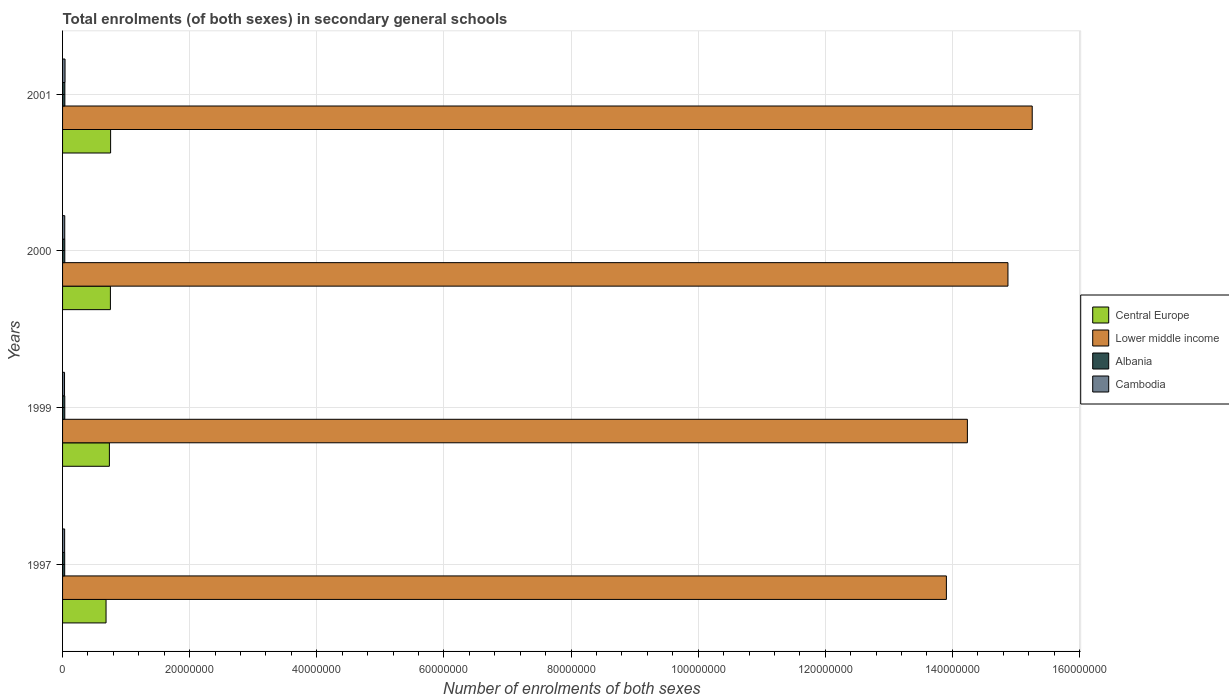How many groups of bars are there?
Provide a succinct answer. 4. How many bars are there on the 4th tick from the top?
Provide a short and direct response. 4. How many bars are there on the 2nd tick from the bottom?
Provide a succinct answer. 4. What is the label of the 4th group of bars from the top?
Offer a terse response. 1997. In how many cases, is the number of bars for a given year not equal to the number of legend labels?
Make the answer very short. 0. What is the number of enrolments in secondary schools in Central Europe in 1999?
Your answer should be very brief. 7.37e+06. Across all years, what is the maximum number of enrolments in secondary schools in Central Europe?
Offer a terse response. 7.56e+06. Across all years, what is the minimum number of enrolments in secondary schools in Albania?
Give a very brief answer. 3.34e+05. In which year was the number of enrolments in secondary schools in Cambodia maximum?
Keep it short and to the point. 2001. What is the total number of enrolments in secondary schools in Central Europe in the graph?
Provide a succinct answer. 2.93e+07. What is the difference between the number of enrolments in secondary schools in Lower middle income in 1999 and that in 2000?
Provide a succinct answer. -6.38e+06. What is the difference between the number of enrolments in secondary schools in Central Europe in 1997 and the number of enrolments in secondary schools in Lower middle income in 1999?
Your response must be concise. -1.36e+08. What is the average number of enrolments in secondary schools in Cambodia per year?
Your answer should be very brief. 3.42e+05. In the year 1999, what is the difference between the number of enrolments in secondary schools in Central Europe and number of enrolments in secondary schools in Cambodia?
Your answer should be very brief. 7.06e+06. In how many years, is the number of enrolments in secondary schools in Albania greater than 44000000 ?
Your answer should be very brief. 0. What is the ratio of the number of enrolments in secondary schools in Cambodia in 1999 to that in 2000?
Ensure brevity in your answer.  0.9. Is the number of enrolments in secondary schools in Albania in 2000 less than that in 2001?
Your response must be concise. Yes. Is the difference between the number of enrolments in secondary schools in Central Europe in 2000 and 2001 greater than the difference between the number of enrolments in secondary schools in Cambodia in 2000 and 2001?
Provide a succinct answer. Yes. What is the difference between the highest and the second highest number of enrolments in secondary schools in Central Europe?
Keep it short and to the point. 3.40e+04. What is the difference between the highest and the lowest number of enrolments in secondary schools in Lower middle income?
Ensure brevity in your answer.  1.35e+07. In how many years, is the number of enrolments in secondary schools in Lower middle income greater than the average number of enrolments in secondary schools in Lower middle income taken over all years?
Ensure brevity in your answer.  2. Is the sum of the number of enrolments in secondary schools in Central Europe in 1999 and 2000 greater than the maximum number of enrolments in secondary schools in Lower middle income across all years?
Provide a short and direct response. No. Is it the case that in every year, the sum of the number of enrolments in secondary schools in Albania and number of enrolments in secondary schools in Lower middle income is greater than the sum of number of enrolments in secondary schools in Cambodia and number of enrolments in secondary schools in Central Europe?
Give a very brief answer. Yes. What does the 4th bar from the top in 1997 represents?
Give a very brief answer. Central Europe. What does the 4th bar from the bottom in 2001 represents?
Make the answer very short. Cambodia. Is it the case that in every year, the sum of the number of enrolments in secondary schools in Albania and number of enrolments in secondary schools in Central Europe is greater than the number of enrolments in secondary schools in Lower middle income?
Provide a succinct answer. No. How many bars are there?
Give a very brief answer. 16. What is the difference between two consecutive major ticks on the X-axis?
Keep it short and to the point. 2.00e+07. Where does the legend appear in the graph?
Give a very brief answer. Center right. What is the title of the graph?
Offer a very short reply. Total enrolments (of both sexes) in secondary general schools. Does "Paraguay" appear as one of the legend labels in the graph?
Provide a succinct answer. No. What is the label or title of the X-axis?
Provide a short and direct response. Number of enrolments of both sexes. What is the Number of enrolments of both sexes in Central Europe in 1997?
Your response must be concise. 6.84e+06. What is the Number of enrolments of both sexes of Lower middle income in 1997?
Offer a terse response. 1.39e+08. What is the Number of enrolments of both sexes of Albania in 1997?
Ensure brevity in your answer.  3.34e+05. What is the Number of enrolments of both sexes in Cambodia in 1997?
Offer a terse response. 3.28e+05. What is the Number of enrolments of both sexes in Central Europe in 1999?
Your response must be concise. 7.37e+06. What is the Number of enrolments of both sexes in Lower middle income in 1999?
Offer a very short reply. 1.42e+08. What is the Number of enrolments of both sexes in Albania in 1999?
Your answer should be compact. 3.48e+05. What is the Number of enrolments of both sexes in Cambodia in 1999?
Provide a succinct answer. 3.08e+05. What is the Number of enrolments of both sexes of Central Europe in 2000?
Your answer should be compact. 7.53e+06. What is the Number of enrolments of both sexes in Lower middle income in 2000?
Make the answer very short. 1.49e+08. What is the Number of enrolments of both sexes in Albania in 2000?
Provide a short and direct response. 3.51e+05. What is the Number of enrolments of both sexes of Cambodia in 2000?
Offer a very short reply. 3.43e+05. What is the Number of enrolments of both sexes of Central Europe in 2001?
Ensure brevity in your answer.  7.56e+06. What is the Number of enrolments of both sexes in Lower middle income in 2001?
Your response must be concise. 1.53e+08. What is the Number of enrolments of both sexes of Albania in 2001?
Offer a very short reply. 3.62e+05. What is the Number of enrolments of both sexes of Cambodia in 2001?
Offer a very short reply. 3.89e+05. Across all years, what is the maximum Number of enrolments of both sexes in Central Europe?
Offer a very short reply. 7.56e+06. Across all years, what is the maximum Number of enrolments of both sexes of Lower middle income?
Provide a succinct answer. 1.53e+08. Across all years, what is the maximum Number of enrolments of both sexes of Albania?
Keep it short and to the point. 3.62e+05. Across all years, what is the maximum Number of enrolments of both sexes in Cambodia?
Ensure brevity in your answer.  3.89e+05. Across all years, what is the minimum Number of enrolments of both sexes of Central Europe?
Make the answer very short. 6.84e+06. Across all years, what is the minimum Number of enrolments of both sexes in Lower middle income?
Offer a terse response. 1.39e+08. Across all years, what is the minimum Number of enrolments of both sexes in Albania?
Provide a short and direct response. 3.34e+05. Across all years, what is the minimum Number of enrolments of both sexes of Cambodia?
Your response must be concise. 3.08e+05. What is the total Number of enrolments of both sexes in Central Europe in the graph?
Your answer should be compact. 2.93e+07. What is the total Number of enrolments of both sexes of Lower middle income in the graph?
Keep it short and to the point. 5.83e+08. What is the total Number of enrolments of both sexes in Albania in the graph?
Provide a succinct answer. 1.39e+06. What is the total Number of enrolments of both sexes in Cambodia in the graph?
Your response must be concise. 1.37e+06. What is the difference between the Number of enrolments of both sexes in Central Europe in 1997 and that in 1999?
Offer a terse response. -5.25e+05. What is the difference between the Number of enrolments of both sexes of Lower middle income in 1997 and that in 1999?
Your answer should be compact. -3.30e+06. What is the difference between the Number of enrolments of both sexes of Albania in 1997 and that in 1999?
Make the answer very short. -1.48e+04. What is the difference between the Number of enrolments of both sexes in Cambodia in 1997 and that in 1999?
Your response must be concise. 1.94e+04. What is the difference between the Number of enrolments of both sexes in Central Europe in 1997 and that in 2000?
Give a very brief answer. -6.85e+05. What is the difference between the Number of enrolments of both sexes in Lower middle income in 1997 and that in 2000?
Offer a very short reply. -9.69e+06. What is the difference between the Number of enrolments of both sexes of Albania in 1997 and that in 2000?
Ensure brevity in your answer.  -1.76e+04. What is the difference between the Number of enrolments of both sexes of Cambodia in 1997 and that in 2000?
Give a very brief answer. -1.57e+04. What is the difference between the Number of enrolments of both sexes of Central Europe in 1997 and that in 2001?
Offer a very short reply. -7.19e+05. What is the difference between the Number of enrolments of both sexes in Lower middle income in 1997 and that in 2001?
Offer a terse response. -1.35e+07. What is the difference between the Number of enrolments of both sexes of Albania in 1997 and that in 2001?
Provide a succinct answer. -2.80e+04. What is the difference between the Number of enrolments of both sexes in Cambodia in 1997 and that in 2001?
Offer a terse response. -6.15e+04. What is the difference between the Number of enrolments of both sexes of Central Europe in 1999 and that in 2000?
Make the answer very short. -1.60e+05. What is the difference between the Number of enrolments of both sexes of Lower middle income in 1999 and that in 2000?
Provide a short and direct response. -6.38e+06. What is the difference between the Number of enrolments of both sexes in Albania in 1999 and that in 2000?
Offer a terse response. -2794. What is the difference between the Number of enrolments of both sexes in Cambodia in 1999 and that in 2000?
Offer a terse response. -3.51e+04. What is the difference between the Number of enrolments of both sexes of Central Europe in 1999 and that in 2001?
Your answer should be very brief. -1.94e+05. What is the difference between the Number of enrolments of both sexes of Lower middle income in 1999 and that in 2001?
Provide a short and direct response. -1.02e+07. What is the difference between the Number of enrolments of both sexes in Albania in 1999 and that in 2001?
Provide a short and direct response. -1.32e+04. What is the difference between the Number of enrolments of both sexes of Cambodia in 1999 and that in 2001?
Ensure brevity in your answer.  -8.09e+04. What is the difference between the Number of enrolments of both sexes in Central Europe in 2000 and that in 2001?
Provide a succinct answer. -3.40e+04. What is the difference between the Number of enrolments of both sexes of Lower middle income in 2000 and that in 2001?
Your response must be concise. -3.82e+06. What is the difference between the Number of enrolments of both sexes in Albania in 2000 and that in 2001?
Offer a very short reply. -1.04e+04. What is the difference between the Number of enrolments of both sexes of Cambodia in 2000 and that in 2001?
Provide a short and direct response. -4.57e+04. What is the difference between the Number of enrolments of both sexes of Central Europe in 1997 and the Number of enrolments of both sexes of Lower middle income in 1999?
Your answer should be very brief. -1.36e+08. What is the difference between the Number of enrolments of both sexes of Central Europe in 1997 and the Number of enrolments of both sexes of Albania in 1999?
Make the answer very short. 6.49e+06. What is the difference between the Number of enrolments of both sexes in Central Europe in 1997 and the Number of enrolments of both sexes in Cambodia in 1999?
Your answer should be very brief. 6.53e+06. What is the difference between the Number of enrolments of both sexes in Lower middle income in 1997 and the Number of enrolments of both sexes in Albania in 1999?
Your answer should be compact. 1.39e+08. What is the difference between the Number of enrolments of both sexes in Lower middle income in 1997 and the Number of enrolments of both sexes in Cambodia in 1999?
Ensure brevity in your answer.  1.39e+08. What is the difference between the Number of enrolments of both sexes of Albania in 1997 and the Number of enrolments of both sexes of Cambodia in 1999?
Keep it short and to the point. 2.54e+04. What is the difference between the Number of enrolments of both sexes in Central Europe in 1997 and the Number of enrolments of both sexes in Lower middle income in 2000?
Offer a very short reply. -1.42e+08. What is the difference between the Number of enrolments of both sexes of Central Europe in 1997 and the Number of enrolments of both sexes of Albania in 2000?
Your response must be concise. 6.49e+06. What is the difference between the Number of enrolments of both sexes of Central Europe in 1997 and the Number of enrolments of both sexes of Cambodia in 2000?
Provide a succinct answer. 6.50e+06. What is the difference between the Number of enrolments of both sexes in Lower middle income in 1997 and the Number of enrolments of both sexes in Albania in 2000?
Offer a very short reply. 1.39e+08. What is the difference between the Number of enrolments of both sexes in Lower middle income in 1997 and the Number of enrolments of both sexes in Cambodia in 2000?
Ensure brevity in your answer.  1.39e+08. What is the difference between the Number of enrolments of both sexes of Albania in 1997 and the Number of enrolments of both sexes of Cambodia in 2000?
Give a very brief answer. -9785. What is the difference between the Number of enrolments of both sexes of Central Europe in 1997 and the Number of enrolments of both sexes of Lower middle income in 2001?
Provide a succinct answer. -1.46e+08. What is the difference between the Number of enrolments of both sexes in Central Europe in 1997 and the Number of enrolments of both sexes in Albania in 2001?
Give a very brief answer. 6.48e+06. What is the difference between the Number of enrolments of both sexes in Central Europe in 1997 and the Number of enrolments of both sexes in Cambodia in 2001?
Offer a very short reply. 6.45e+06. What is the difference between the Number of enrolments of both sexes in Lower middle income in 1997 and the Number of enrolments of both sexes in Albania in 2001?
Your response must be concise. 1.39e+08. What is the difference between the Number of enrolments of both sexes of Lower middle income in 1997 and the Number of enrolments of both sexes of Cambodia in 2001?
Your answer should be compact. 1.39e+08. What is the difference between the Number of enrolments of both sexes of Albania in 1997 and the Number of enrolments of both sexes of Cambodia in 2001?
Offer a very short reply. -5.55e+04. What is the difference between the Number of enrolments of both sexes of Central Europe in 1999 and the Number of enrolments of both sexes of Lower middle income in 2000?
Your answer should be compact. -1.41e+08. What is the difference between the Number of enrolments of both sexes of Central Europe in 1999 and the Number of enrolments of both sexes of Albania in 2000?
Give a very brief answer. 7.01e+06. What is the difference between the Number of enrolments of both sexes in Central Europe in 1999 and the Number of enrolments of both sexes in Cambodia in 2000?
Ensure brevity in your answer.  7.02e+06. What is the difference between the Number of enrolments of both sexes in Lower middle income in 1999 and the Number of enrolments of both sexes in Albania in 2000?
Make the answer very short. 1.42e+08. What is the difference between the Number of enrolments of both sexes of Lower middle income in 1999 and the Number of enrolments of both sexes of Cambodia in 2000?
Offer a very short reply. 1.42e+08. What is the difference between the Number of enrolments of both sexes in Albania in 1999 and the Number of enrolments of both sexes in Cambodia in 2000?
Keep it short and to the point. 5061. What is the difference between the Number of enrolments of both sexes in Central Europe in 1999 and the Number of enrolments of both sexes in Lower middle income in 2001?
Your answer should be very brief. -1.45e+08. What is the difference between the Number of enrolments of both sexes of Central Europe in 1999 and the Number of enrolments of both sexes of Albania in 2001?
Your response must be concise. 7.00e+06. What is the difference between the Number of enrolments of both sexes in Central Europe in 1999 and the Number of enrolments of both sexes in Cambodia in 2001?
Offer a very short reply. 6.98e+06. What is the difference between the Number of enrolments of both sexes of Lower middle income in 1999 and the Number of enrolments of both sexes of Albania in 2001?
Ensure brevity in your answer.  1.42e+08. What is the difference between the Number of enrolments of both sexes in Lower middle income in 1999 and the Number of enrolments of both sexes in Cambodia in 2001?
Keep it short and to the point. 1.42e+08. What is the difference between the Number of enrolments of both sexes of Albania in 1999 and the Number of enrolments of both sexes of Cambodia in 2001?
Offer a terse response. -4.07e+04. What is the difference between the Number of enrolments of both sexes of Central Europe in 2000 and the Number of enrolments of both sexes of Lower middle income in 2001?
Offer a terse response. -1.45e+08. What is the difference between the Number of enrolments of both sexes of Central Europe in 2000 and the Number of enrolments of both sexes of Albania in 2001?
Your answer should be compact. 7.16e+06. What is the difference between the Number of enrolments of both sexes of Central Europe in 2000 and the Number of enrolments of both sexes of Cambodia in 2001?
Provide a short and direct response. 7.14e+06. What is the difference between the Number of enrolments of both sexes in Lower middle income in 2000 and the Number of enrolments of both sexes in Albania in 2001?
Your answer should be very brief. 1.48e+08. What is the difference between the Number of enrolments of both sexes of Lower middle income in 2000 and the Number of enrolments of both sexes of Cambodia in 2001?
Give a very brief answer. 1.48e+08. What is the difference between the Number of enrolments of both sexes in Albania in 2000 and the Number of enrolments of both sexes in Cambodia in 2001?
Your answer should be compact. -3.79e+04. What is the average Number of enrolments of both sexes in Central Europe per year?
Offer a terse response. 7.32e+06. What is the average Number of enrolments of both sexes of Lower middle income per year?
Give a very brief answer. 1.46e+08. What is the average Number of enrolments of both sexes of Albania per year?
Offer a very short reply. 3.49e+05. What is the average Number of enrolments of both sexes of Cambodia per year?
Your response must be concise. 3.42e+05. In the year 1997, what is the difference between the Number of enrolments of both sexes of Central Europe and Number of enrolments of both sexes of Lower middle income?
Your answer should be very brief. -1.32e+08. In the year 1997, what is the difference between the Number of enrolments of both sexes of Central Europe and Number of enrolments of both sexes of Albania?
Your response must be concise. 6.51e+06. In the year 1997, what is the difference between the Number of enrolments of both sexes of Central Europe and Number of enrolments of both sexes of Cambodia?
Your response must be concise. 6.51e+06. In the year 1997, what is the difference between the Number of enrolments of both sexes of Lower middle income and Number of enrolments of both sexes of Albania?
Keep it short and to the point. 1.39e+08. In the year 1997, what is the difference between the Number of enrolments of both sexes in Lower middle income and Number of enrolments of both sexes in Cambodia?
Ensure brevity in your answer.  1.39e+08. In the year 1997, what is the difference between the Number of enrolments of both sexes in Albania and Number of enrolments of both sexes in Cambodia?
Your answer should be compact. 5957. In the year 1999, what is the difference between the Number of enrolments of both sexes of Central Europe and Number of enrolments of both sexes of Lower middle income?
Provide a succinct answer. -1.35e+08. In the year 1999, what is the difference between the Number of enrolments of both sexes in Central Europe and Number of enrolments of both sexes in Albania?
Offer a terse response. 7.02e+06. In the year 1999, what is the difference between the Number of enrolments of both sexes of Central Europe and Number of enrolments of both sexes of Cambodia?
Provide a short and direct response. 7.06e+06. In the year 1999, what is the difference between the Number of enrolments of both sexes in Lower middle income and Number of enrolments of both sexes in Albania?
Offer a very short reply. 1.42e+08. In the year 1999, what is the difference between the Number of enrolments of both sexes of Lower middle income and Number of enrolments of both sexes of Cambodia?
Your answer should be very brief. 1.42e+08. In the year 1999, what is the difference between the Number of enrolments of both sexes in Albania and Number of enrolments of both sexes in Cambodia?
Provide a succinct answer. 4.02e+04. In the year 2000, what is the difference between the Number of enrolments of both sexes in Central Europe and Number of enrolments of both sexes in Lower middle income?
Keep it short and to the point. -1.41e+08. In the year 2000, what is the difference between the Number of enrolments of both sexes of Central Europe and Number of enrolments of both sexes of Albania?
Your response must be concise. 7.17e+06. In the year 2000, what is the difference between the Number of enrolments of both sexes in Central Europe and Number of enrolments of both sexes in Cambodia?
Your response must be concise. 7.18e+06. In the year 2000, what is the difference between the Number of enrolments of both sexes of Lower middle income and Number of enrolments of both sexes of Albania?
Offer a terse response. 1.48e+08. In the year 2000, what is the difference between the Number of enrolments of both sexes in Lower middle income and Number of enrolments of both sexes in Cambodia?
Make the answer very short. 1.48e+08. In the year 2000, what is the difference between the Number of enrolments of both sexes of Albania and Number of enrolments of both sexes of Cambodia?
Your response must be concise. 7855. In the year 2001, what is the difference between the Number of enrolments of both sexes of Central Europe and Number of enrolments of both sexes of Lower middle income?
Offer a very short reply. -1.45e+08. In the year 2001, what is the difference between the Number of enrolments of both sexes in Central Europe and Number of enrolments of both sexes in Albania?
Offer a very short reply. 7.20e+06. In the year 2001, what is the difference between the Number of enrolments of both sexes in Central Europe and Number of enrolments of both sexes in Cambodia?
Ensure brevity in your answer.  7.17e+06. In the year 2001, what is the difference between the Number of enrolments of both sexes in Lower middle income and Number of enrolments of both sexes in Albania?
Offer a very short reply. 1.52e+08. In the year 2001, what is the difference between the Number of enrolments of both sexes of Lower middle income and Number of enrolments of both sexes of Cambodia?
Ensure brevity in your answer.  1.52e+08. In the year 2001, what is the difference between the Number of enrolments of both sexes in Albania and Number of enrolments of both sexes in Cambodia?
Your response must be concise. -2.75e+04. What is the ratio of the Number of enrolments of both sexes in Central Europe in 1997 to that in 1999?
Your answer should be compact. 0.93. What is the ratio of the Number of enrolments of both sexes of Lower middle income in 1997 to that in 1999?
Give a very brief answer. 0.98. What is the ratio of the Number of enrolments of both sexes in Albania in 1997 to that in 1999?
Make the answer very short. 0.96. What is the ratio of the Number of enrolments of both sexes of Cambodia in 1997 to that in 1999?
Keep it short and to the point. 1.06. What is the ratio of the Number of enrolments of both sexes of Central Europe in 1997 to that in 2000?
Your answer should be very brief. 0.91. What is the ratio of the Number of enrolments of both sexes of Lower middle income in 1997 to that in 2000?
Give a very brief answer. 0.93. What is the ratio of the Number of enrolments of both sexes of Albania in 1997 to that in 2000?
Offer a very short reply. 0.95. What is the ratio of the Number of enrolments of both sexes in Cambodia in 1997 to that in 2000?
Provide a short and direct response. 0.95. What is the ratio of the Number of enrolments of both sexes in Central Europe in 1997 to that in 2001?
Your response must be concise. 0.9. What is the ratio of the Number of enrolments of both sexes of Lower middle income in 1997 to that in 2001?
Provide a short and direct response. 0.91. What is the ratio of the Number of enrolments of both sexes in Albania in 1997 to that in 2001?
Give a very brief answer. 0.92. What is the ratio of the Number of enrolments of both sexes in Cambodia in 1997 to that in 2001?
Your answer should be compact. 0.84. What is the ratio of the Number of enrolments of both sexes in Central Europe in 1999 to that in 2000?
Give a very brief answer. 0.98. What is the ratio of the Number of enrolments of both sexes of Lower middle income in 1999 to that in 2000?
Give a very brief answer. 0.96. What is the ratio of the Number of enrolments of both sexes of Albania in 1999 to that in 2000?
Offer a terse response. 0.99. What is the ratio of the Number of enrolments of both sexes of Cambodia in 1999 to that in 2000?
Give a very brief answer. 0.9. What is the ratio of the Number of enrolments of both sexes of Central Europe in 1999 to that in 2001?
Offer a very short reply. 0.97. What is the ratio of the Number of enrolments of both sexes of Lower middle income in 1999 to that in 2001?
Offer a terse response. 0.93. What is the ratio of the Number of enrolments of both sexes in Albania in 1999 to that in 2001?
Provide a succinct answer. 0.96. What is the ratio of the Number of enrolments of both sexes in Cambodia in 1999 to that in 2001?
Ensure brevity in your answer.  0.79. What is the ratio of the Number of enrolments of both sexes in Lower middle income in 2000 to that in 2001?
Ensure brevity in your answer.  0.97. What is the ratio of the Number of enrolments of both sexes of Albania in 2000 to that in 2001?
Your response must be concise. 0.97. What is the ratio of the Number of enrolments of both sexes of Cambodia in 2000 to that in 2001?
Your answer should be compact. 0.88. What is the difference between the highest and the second highest Number of enrolments of both sexes of Central Europe?
Make the answer very short. 3.40e+04. What is the difference between the highest and the second highest Number of enrolments of both sexes in Lower middle income?
Ensure brevity in your answer.  3.82e+06. What is the difference between the highest and the second highest Number of enrolments of both sexes in Albania?
Make the answer very short. 1.04e+04. What is the difference between the highest and the second highest Number of enrolments of both sexes of Cambodia?
Keep it short and to the point. 4.57e+04. What is the difference between the highest and the lowest Number of enrolments of both sexes of Central Europe?
Provide a succinct answer. 7.19e+05. What is the difference between the highest and the lowest Number of enrolments of both sexes in Lower middle income?
Give a very brief answer. 1.35e+07. What is the difference between the highest and the lowest Number of enrolments of both sexes in Albania?
Your answer should be very brief. 2.80e+04. What is the difference between the highest and the lowest Number of enrolments of both sexes of Cambodia?
Your answer should be very brief. 8.09e+04. 